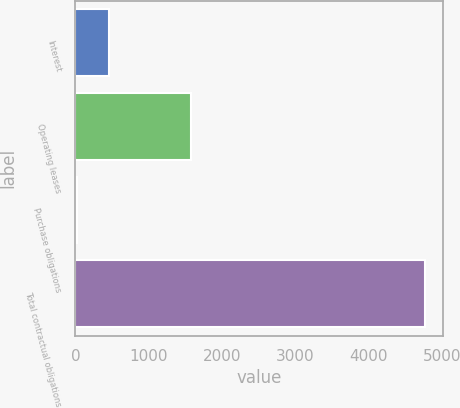<chart> <loc_0><loc_0><loc_500><loc_500><bar_chart><fcel>Interest<fcel>Operating leases<fcel>Purchase obligations<fcel>Total contractual obligations<nl><fcel>458.6<fcel>1580<fcel>28<fcel>4764.6<nl></chart> 